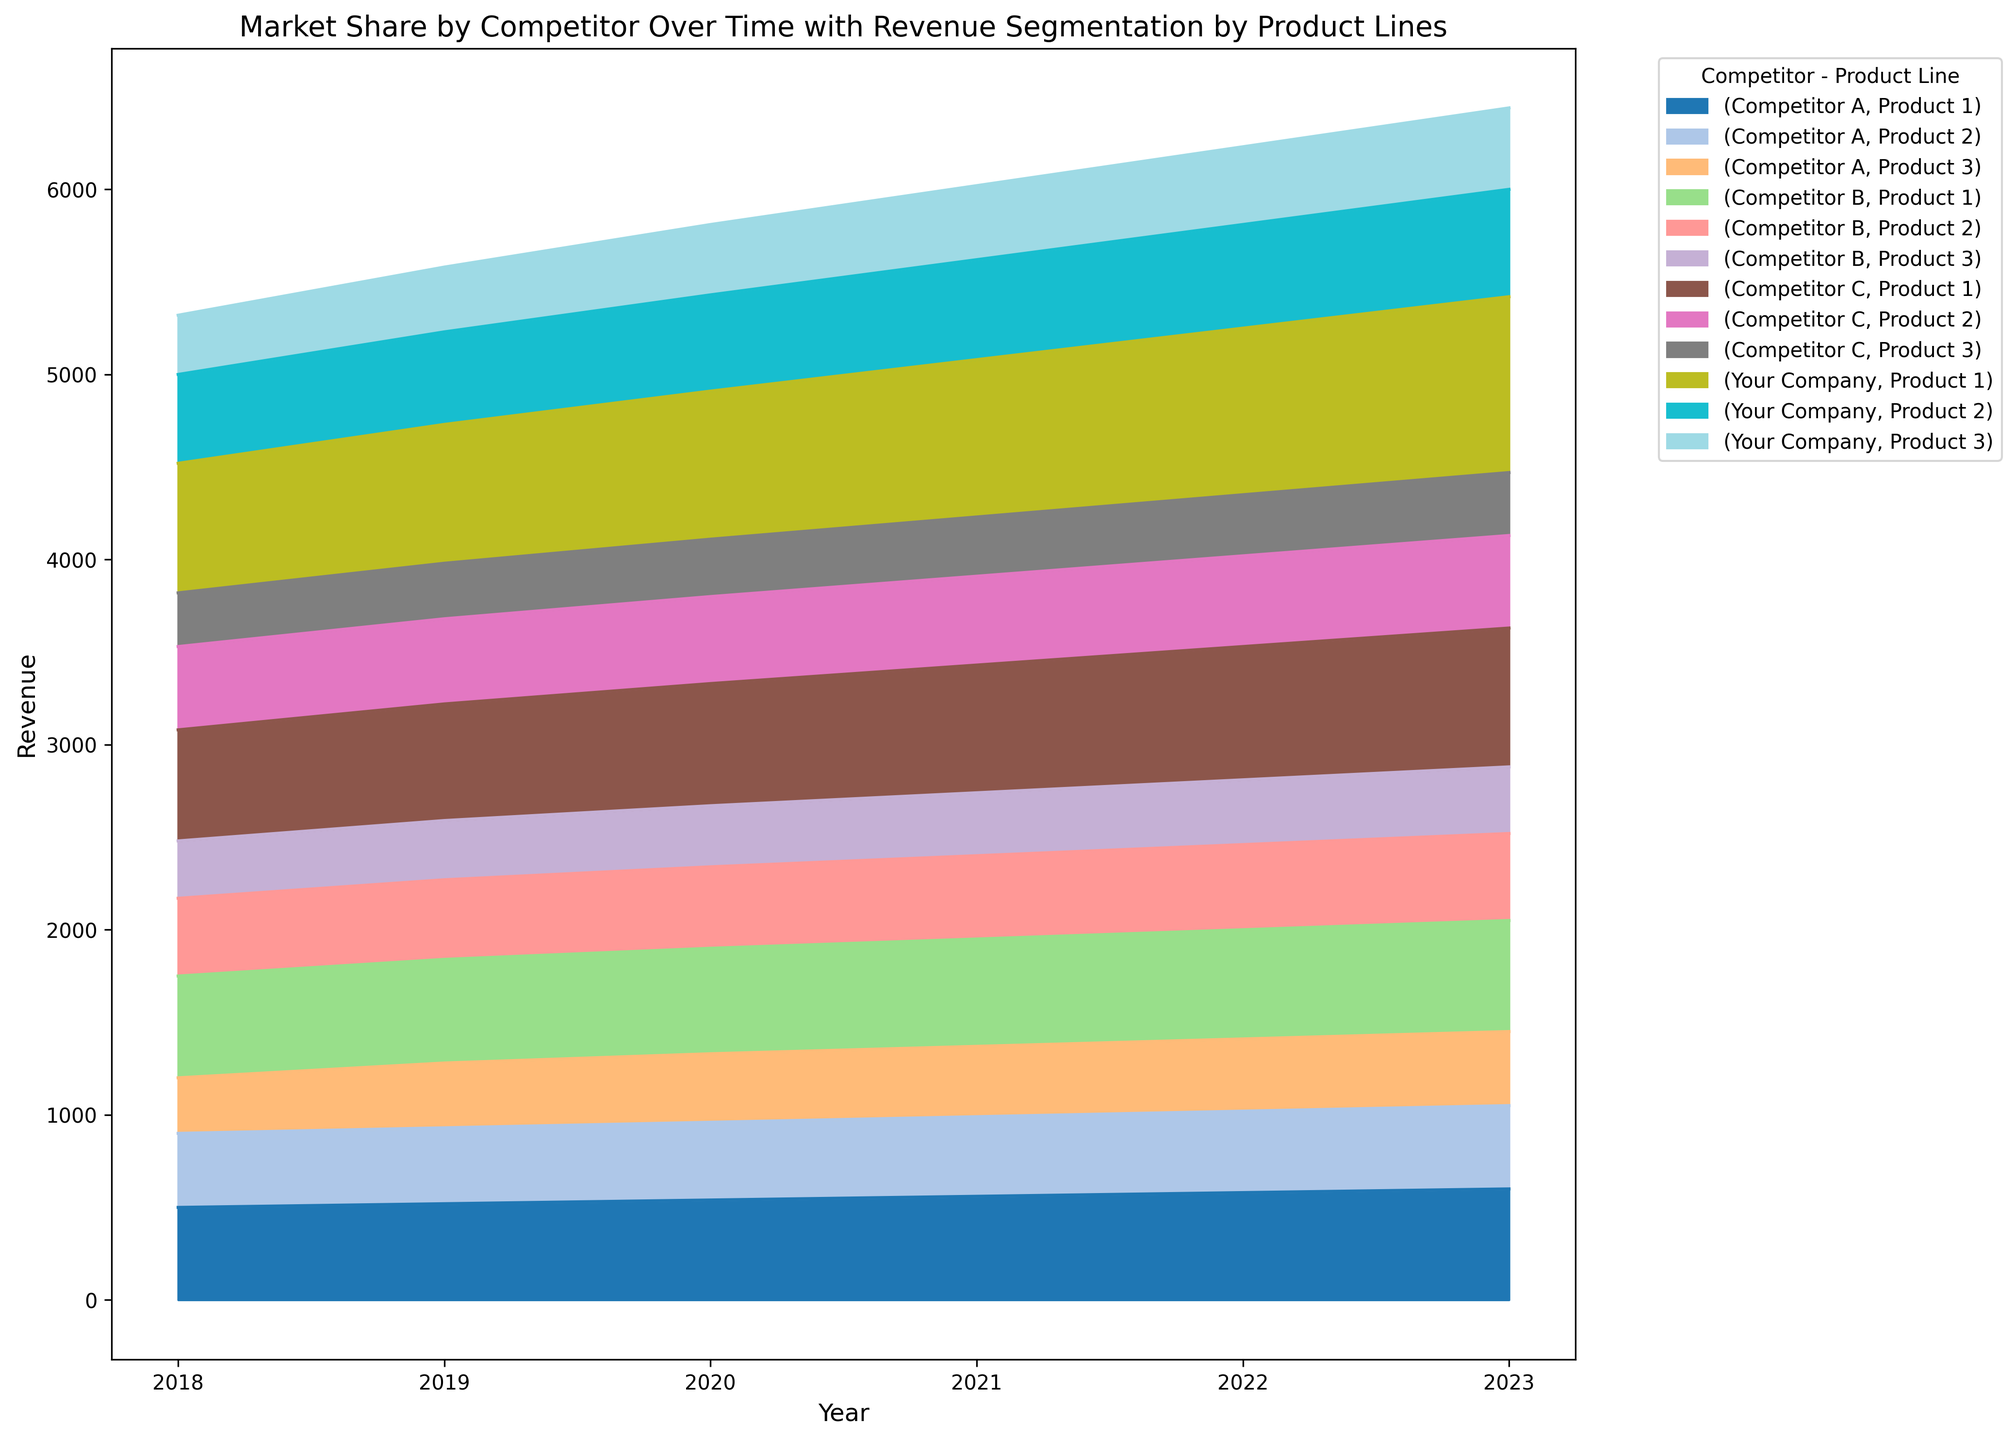What's the overall trend of Your Company's revenue from 2018 to 2023? To determine the overall trend, we observe the stacked areas corresponding to Your Company's Product 1, Product 2, and Product 3. The total stacked area for Your Company grows each year from 2018 to 2023, showing an upward trend.
Answer: Upward trend How does Competitor B's revenue segmentation by product lines compare to Competitor A's in 2021? To compare, look at the segments for each product line for Competitor B and Competitor A in 2021. Competitor B’s revenue distribution is higher for Product 1 and Product 2, but slightly lower for Product 3 compared to Competitor A.
Answer: Higher in Product 1 and Product 2, slightly lower in Product 3 Which competitor experienced the most growth in total revenue from 2018 to 2023? To determine this, compare the total heights of the stacked areas for each competitor in 2018 and 2023. Competitor C shows a significant increase in stack height, indicating the most growth.
Answer: Competitor C What was the combined revenue for Your Company and Competitor A in 2022 for Product 1? Identify the height/area segment corresponding to Product 1 for Your Company and Competitor A in 2022, then sum their revenues: 1900 (Your Company) + 1580 (Competitor A) = 3480.
Answer: 3480 Did any competitor’s revenue for Product 2 remain constant or decrease between any two consecutive years? Scan the segments for Product 2 for each competitor across the years. Competitor A’s revenue for Product 2 remained flat from 2021 to 2022, and Competitor B's decreased slightly from 2020 to 2021.
Answer: Yes, Competitor A (2021-2022), Competitor B (2020-2021) Which product line contributed the most to the total revenue of Competitor C in 2023? Inspect the height of the different segments (Product 1, Product 2, and Product 3) for Competitor C in 2023. Product 1 has the tallest segment.
Answer: Product 1 What's the difference in total revenue between Competitor B and Competitor C in 2023? Calculate the total stacked height for each competitor's revenue in 2023. Competitor B: 1600 + 2470 + 360 = 4430, Competitor C: 1750 + 2500 + 340 = 4590. Then find the difference: 4590 - 4430 = 160.
Answer: 160 How does the revenue distribution among the product lines for Your Company in 2023 visually appear compared to 2018? Compare the heights and areas of individual product line segments for Your Company between the years. All product segments appear taller and larger in 2023 compared to 2018, showing growth across all product lines.
Answer: Taller and larger in 2023 Considering all years, which product line remains the most consistent in terms of revenue for Competitor A? Examine the height of each product segment (Product 1, Product 2, and Product 3) over the years for Competitor A. Product 2 shows the smallest fluctuations, indicating consistency.
Answer: Product 2 What overall market trend can be observed from 2018 to 2023 for Competitors A, B, and C combined? Look at the combined stacked areas of Competitors A, B, and C over the years. The overall height of the stacked regions grows, indicating an increasing market share trend for Competitors A, B, and C combined from 2018 to 2023.
Answer: Increasing market share 